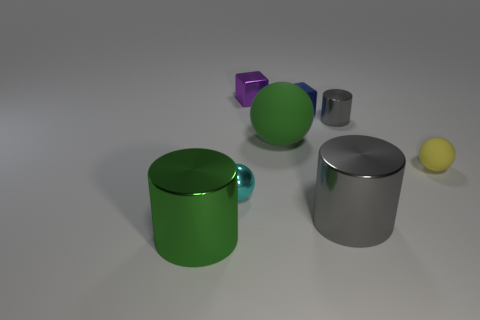Subtract all purple spheres. Subtract all red cylinders. How many spheres are left? 3 Add 2 yellow objects. How many objects exist? 10 Subtract all balls. How many objects are left? 5 Subtract all cyan metal cubes. Subtract all metal cylinders. How many objects are left? 5 Add 2 small yellow objects. How many small yellow objects are left? 3 Add 6 small matte objects. How many small matte objects exist? 7 Subtract 0 yellow cylinders. How many objects are left? 8 